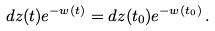<formula> <loc_0><loc_0><loc_500><loc_500>d z ( t ) e ^ { - w ( t ) } = d z ( t _ { 0 } ) e ^ { - w ( t _ { 0 } ) } \, .</formula> 